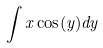<formula> <loc_0><loc_0><loc_500><loc_500>\int x \cos ( y ) d y</formula> 